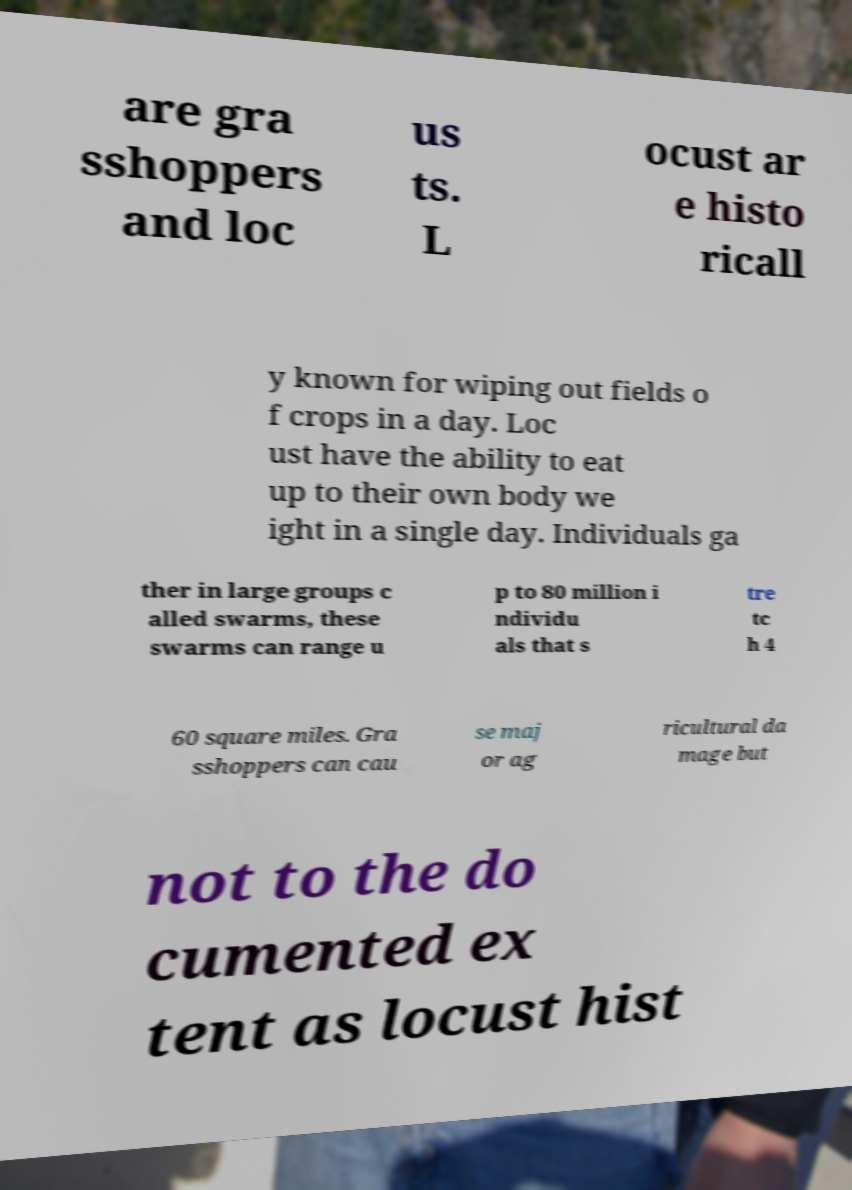For documentation purposes, I need the text within this image transcribed. Could you provide that? are gra sshoppers and loc us ts. L ocust ar e histo ricall y known for wiping out fields o f crops in a day. Loc ust have the ability to eat up to their own body we ight in a single day. Individuals ga ther in large groups c alled swarms, these swarms can range u p to 80 million i ndividu als that s tre tc h 4 60 square miles. Gra sshoppers can cau se maj or ag ricultural da mage but not to the do cumented ex tent as locust hist 